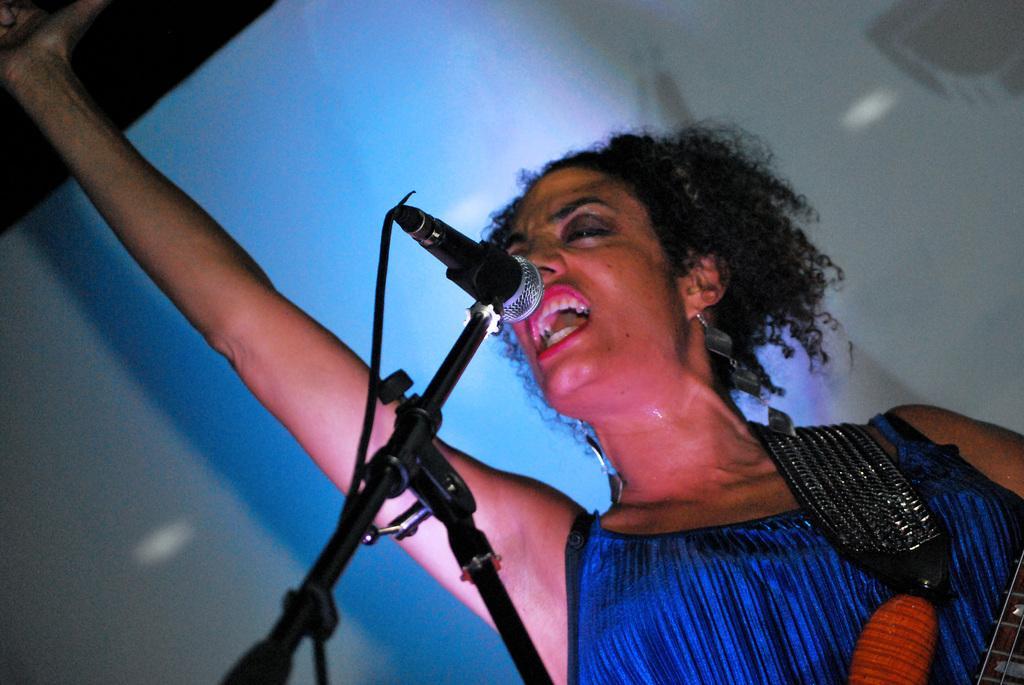Please provide a concise description of this image. In the picture I can see a woman and a microphone. In the background I can see a white color object. 